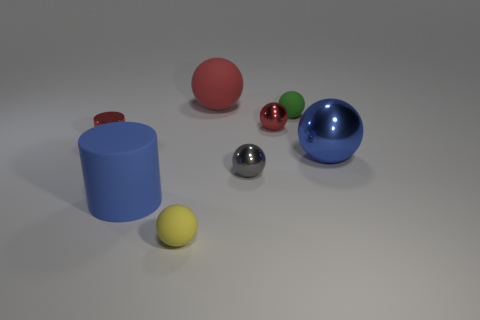Add 1 blue objects. How many objects exist? 9 Subtract all blue spheres. How many spheres are left? 5 Subtract all blue balls. How many balls are left? 5 Subtract 2 cylinders. How many cylinders are left? 0 Subtract all green cylinders. Subtract all red blocks. How many cylinders are left? 2 Subtract all blue balls. How many blue cylinders are left? 1 Subtract all purple rubber cylinders. Subtract all small red things. How many objects are left? 6 Add 1 gray metallic balls. How many gray metallic balls are left? 2 Add 6 large blue rubber objects. How many large blue rubber objects exist? 7 Subtract 0 gray cylinders. How many objects are left? 8 